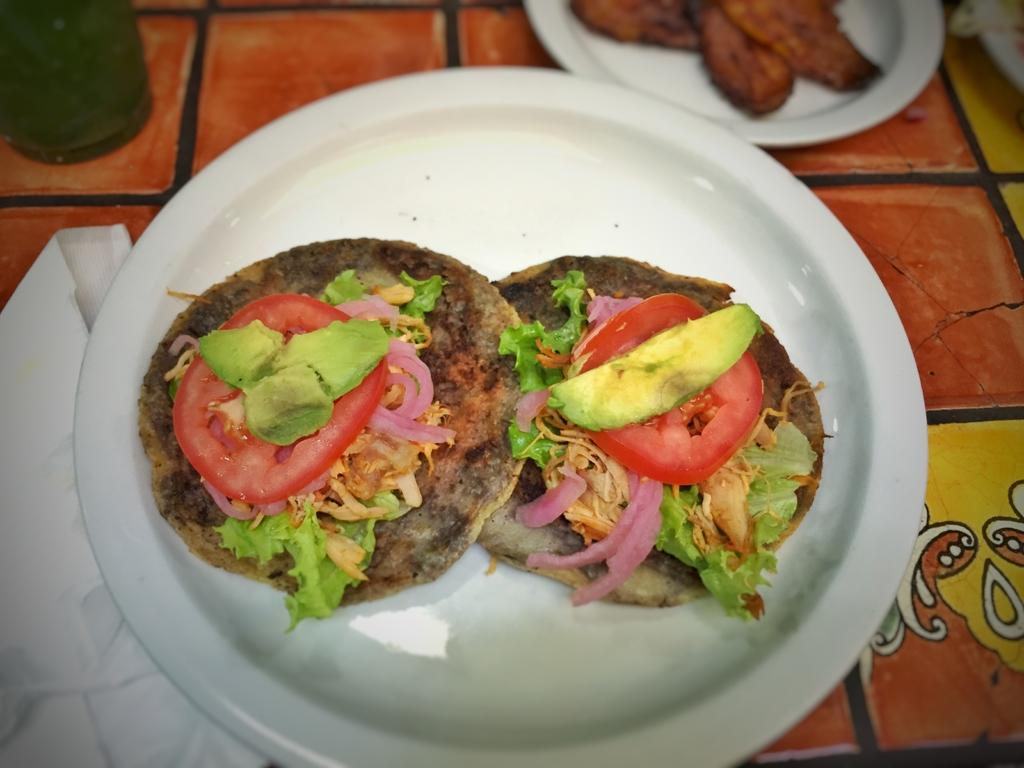What piece of furniture is present in the image? There is a table in the image. How many plates are on the table? There are two plates on the table. What is on the plates? There are food items on the plates. What type of container is visible in the image? There is a bottle in the image. What item can be used for cleaning or wiping in the image? There is a tissue in the image. What type of cake is being served on the plates in the image? There is no cake present in the image; only food items on the plates are visible. 